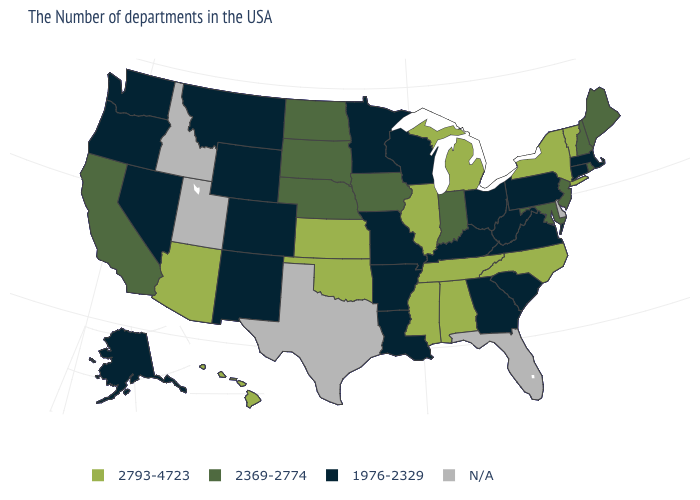What is the value of Nebraska?
Concise answer only. 2369-2774. How many symbols are there in the legend?
Be succinct. 4. What is the lowest value in the USA?
Concise answer only. 1976-2329. How many symbols are there in the legend?
Be succinct. 4. Which states have the lowest value in the South?
Quick response, please. Virginia, South Carolina, West Virginia, Georgia, Kentucky, Louisiana, Arkansas. What is the value of Vermont?
Keep it brief. 2793-4723. Name the states that have a value in the range 2793-4723?
Be succinct. Vermont, New York, North Carolina, Michigan, Alabama, Tennessee, Illinois, Mississippi, Kansas, Oklahoma, Arizona, Hawaii. How many symbols are there in the legend?
Keep it brief. 4. What is the lowest value in the USA?
Quick response, please. 1976-2329. Does New Mexico have the highest value in the USA?
Write a very short answer. No. Does Hawaii have the highest value in the West?
Concise answer only. Yes. Name the states that have a value in the range 2793-4723?
Answer briefly. Vermont, New York, North Carolina, Michigan, Alabama, Tennessee, Illinois, Mississippi, Kansas, Oklahoma, Arizona, Hawaii. Which states have the highest value in the USA?
Give a very brief answer. Vermont, New York, North Carolina, Michigan, Alabama, Tennessee, Illinois, Mississippi, Kansas, Oklahoma, Arizona, Hawaii. 